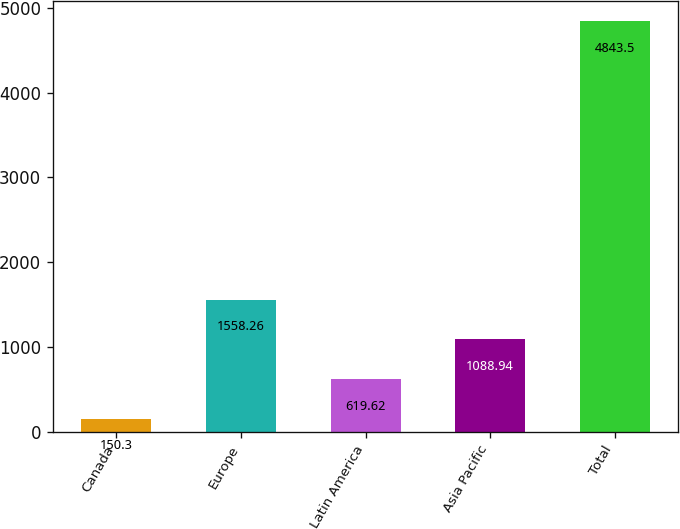Convert chart. <chart><loc_0><loc_0><loc_500><loc_500><bar_chart><fcel>Canada<fcel>Europe<fcel>Latin America<fcel>Asia Pacific<fcel>Total<nl><fcel>150.3<fcel>1558.26<fcel>619.62<fcel>1088.94<fcel>4843.5<nl></chart> 